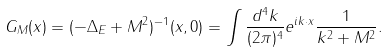<formula> <loc_0><loc_0><loc_500><loc_500>G _ { M } ( x ) = ( - \Delta _ { E } + M ^ { 2 } ) ^ { - 1 } ( x , 0 ) = \int { \frac { d ^ { 4 } k } { ( 2 \pi ) ^ { 4 } } } e ^ { i k \cdot x } { \frac { 1 } { k ^ { 2 } + M ^ { 2 } } } .</formula> 